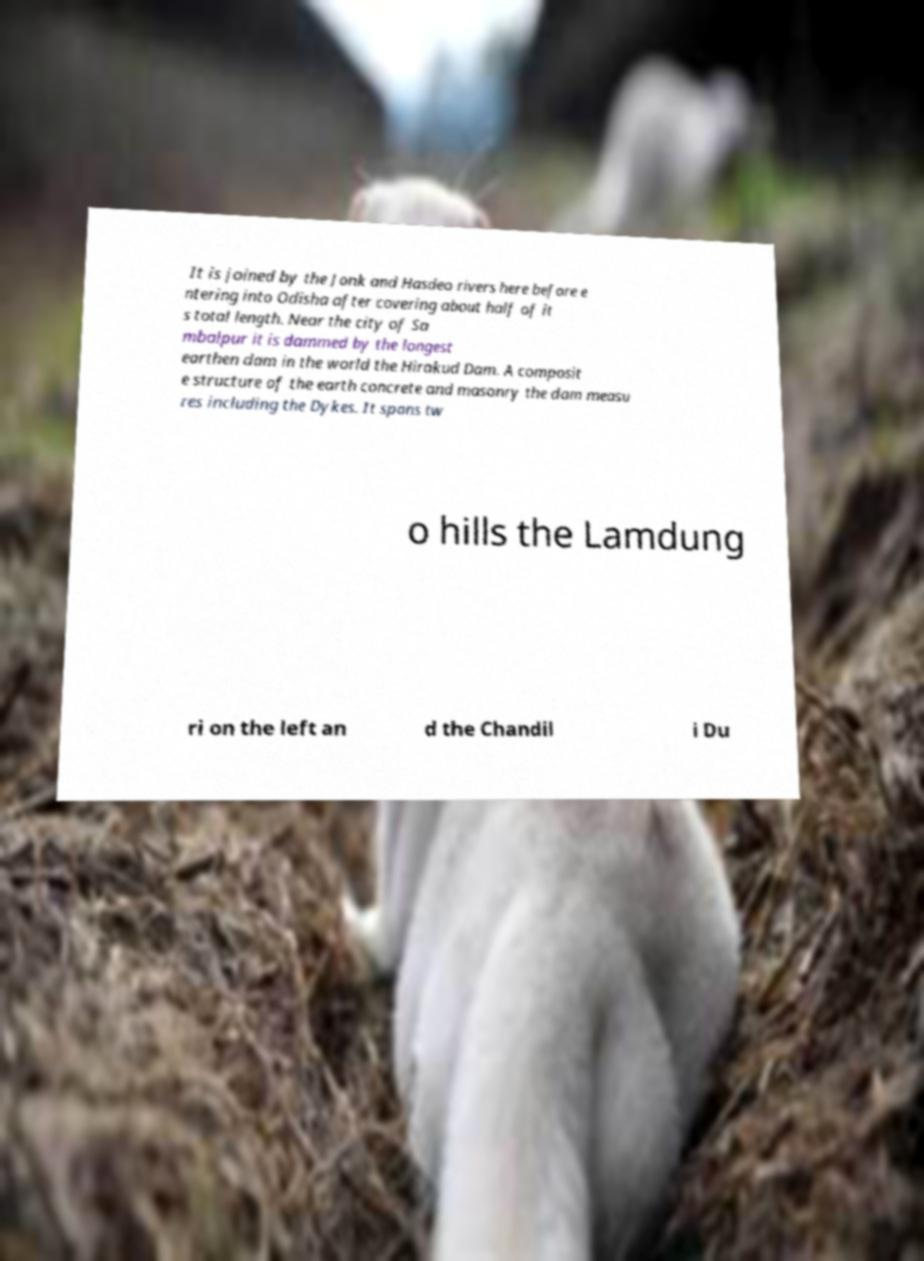Please read and relay the text visible in this image. What does it say? It is joined by the Jonk and Hasdeo rivers here before e ntering into Odisha after covering about half of it s total length. Near the city of Sa mbalpur it is dammed by the longest earthen dam in the world the Hirakud Dam. A composit e structure of the earth concrete and masonry the dam measu res including the Dykes. It spans tw o hills the Lamdung ri on the left an d the Chandil i Du 